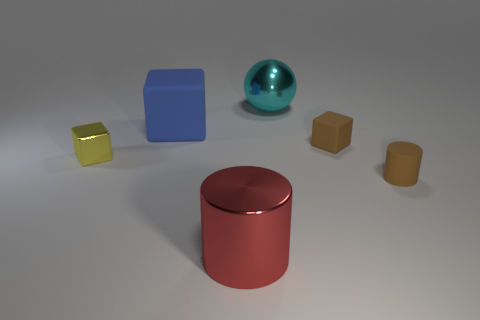What size is the rubber cylinder that is the same color as the tiny rubber cube? The rubber cylinder that shares its color with the smallest rubber cube is also small, measuring relatively similar in size to the tiny cube, suggesting it could be termed a 'small' cylinder in comparison to the other objects presented. 